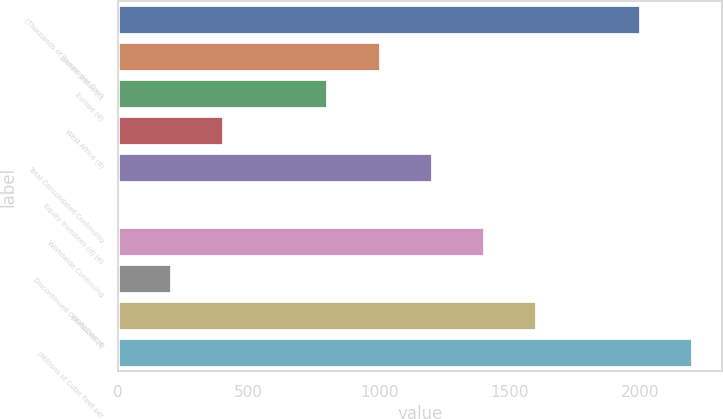<chart> <loc_0><loc_0><loc_500><loc_500><bar_chart><fcel>(Thousands of Barrels per Day)<fcel>United States (c)<fcel>Europe (d)<fcel>West Africa (d)<fcel>Total Consolidated Continuing<fcel>Equity Investees (d) (e)<fcel>Worldwide Continuing<fcel>Discontinued Operations (f)<fcel>WORLDWIDE<fcel>(Millions of Cubic Feet per<nl><fcel>2001<fcel>1005<fcel>805.8<fcel>407.4<fcel>1204.2<fcel>9<fcel>1403.4<fcel>208.2<fcel>1602.6<fcel>2200.2<nl></chart> 